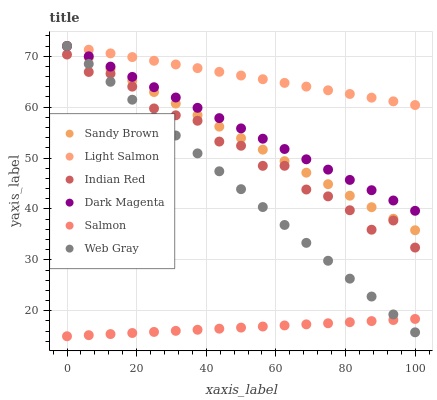Does Salmon have the minimum area under the curve?
Answer yes or no. Yes. Does Light Salmon have the maximum area under the curve?
Answer yes or no. Yes. Does Web Gray have the minimum area under the curve?
Answer yes or no. No. Does Web Gray have the maximum area under the curve?
Answer yes or no. No. Is Salmon the smoothest?
Answer yes or no. Yes. Is Indian Red the roughest?
Answer yes or no. Yes. Is Web Gray the smoothest?
Answer yes or no. No. Is Web Gray the roughest?
Answer yes or no. No. Does Salmon have the lowest value?
Answer yes or no. Yes. Does Web Gray have the lowest value?
Answer yes or no. No. Does Sandy Brown have the highest value?
Answer yes or no. Yes. Does Salmon have the highest value?
Answer yes or no. No. Is Salmon less than Sandy Brown?
Answer yes or no. Yes. Is Indian Red greater than Salmon?
Answer yes or no. Yes. Does Web Gray intersect Light Salmon?
Answer yes or no. Yes. Is Web Gray less than Light Salmon?
Answer yes or no. No. Is Web Gray greater than Light Salmon?
Answer yes or no. No. Does Salmon intersect Sandy Brown?
Answer yes or no. No. 